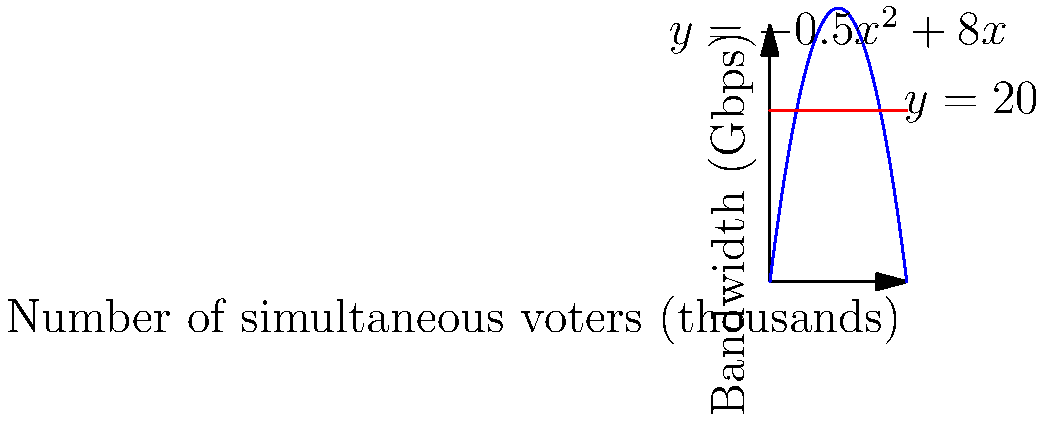An online voting platform's bandwidth utilization is modeled by the function $f(x)=-0.5x^2+8x$, where $x$ is the number of simultaneous voters in thousands and $f(x)$ is the bandwidth in Gbps. The maximum bandwidth capacity is 20 Gbps. What is the maximum number of simultaneous voters the platform can support while staying within the bandwidth limit? To solve this problem, we need to follow these steps:

1) The maximum bandwidth capacity is represented by the equation $y=20$.

2) We need to find the intersection points of $f(x)=-0.5x^2+8x$ and $y=20$.

3) Set up the equation:
   $-0.5x^2+8x = 20$

4) Rearrange to standard form:
   $0.5x^2-8x+20 = 0$

5) This is a quadratic equation. We can solve it using the quadratic formula:
   $x = \frac{-b \pm \sqrt{b^2-4ac}}{2a}$

   Where $a=0.5$, $b=-8$, and $c=20$

6) Plugging in the values:
   $x = \frac{8 \pm \sqrt{64-40}}{1} = \frac{8 \pm \sqrt{24}}{1} = \frac{8 \pm 4.9}{1}$

7) This gives us two solutions:
   $x_1 = 8 + 4.9 = 12.9$
   $x_2 = 8 - 4.9 = 3.1$

8) Since we're looking for the maximum number of voters, we choose the larger solution: 12.9

9) As $x$ represents thousands of voters, we round down to 12,000 voters to stay within the bandwidth limit.
Answer: 12,000 voters 